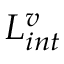Convert formula to latex. <formula><loc_0><loc_0><loc_500><loc_500>L _ { i n t } ^ { v }</formula> 